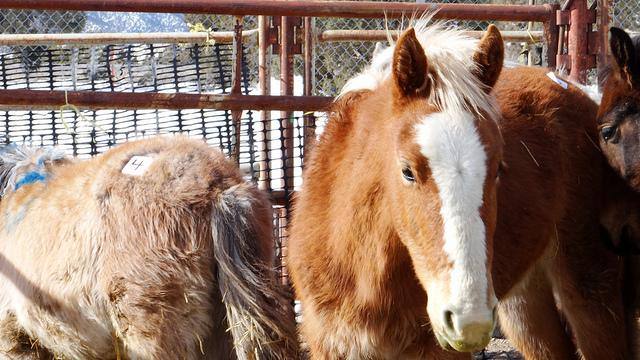What kind of races does this animal run? horse 